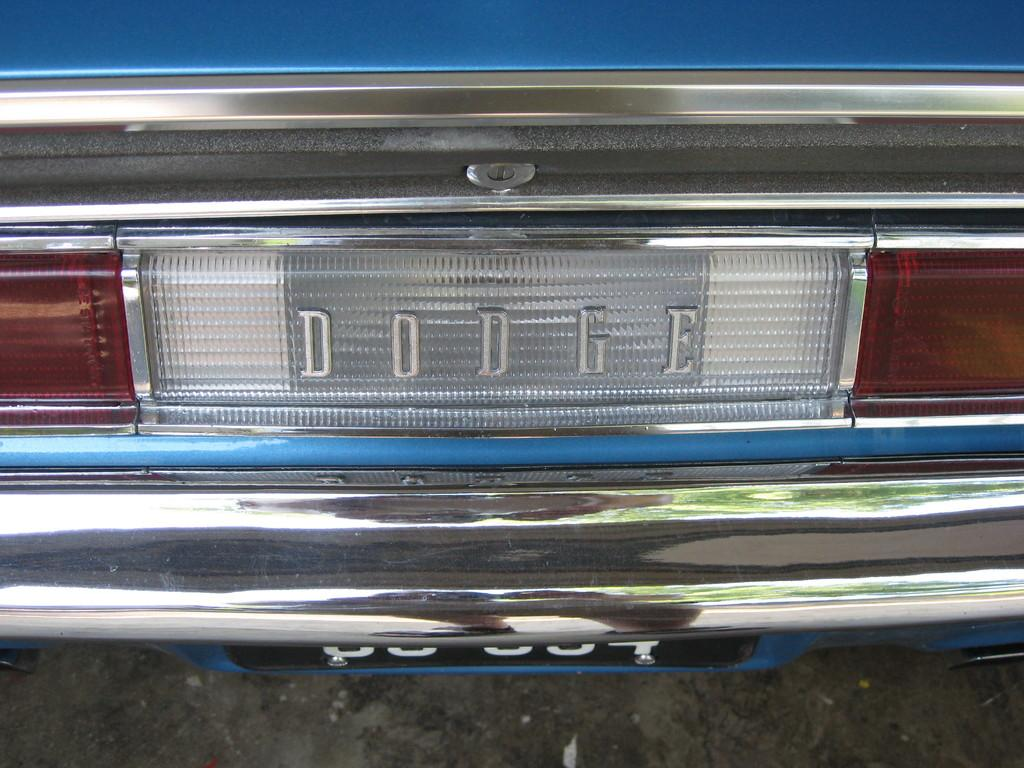Where was the image taken? The image was taken outdoors. What can be seen at the bottom of the image? There is a road at the bottom of the image. What is parked on the road in the middle of the image? A car is parked on the road in the middle of the image. How far away is the bedroom from the car in the image? There is no bedroom present in the image, so it is not possible to determine the distance between the car and a bedroom. 